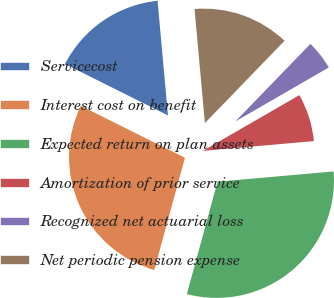<chart> <loc_0><loc_0><loc_500><loc_500><pie_chart><fcel>Servicecost<fcel>Interest cost on benefit<fcel>Expected return on plan assets<fcel>Amortization of prior service<fcel>Recognized net actuarial loss<fcel>Net periodic pension expense<nl><fcel>16.2%<fcel>28.12%<fcel>30.64%<fcel>6.94%<fcel>4.42%<fcel>13.68%<nl></chart> 